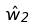<formula> <loc_0><loc_0><loc_500><loc_500>\hat { w } _ { 2 }</formula> 